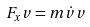Convert formula to latex. <formula><loc_0><loc_0><loc_500><loc_500>F _ { x } v = m \dot { v } v</formula> 